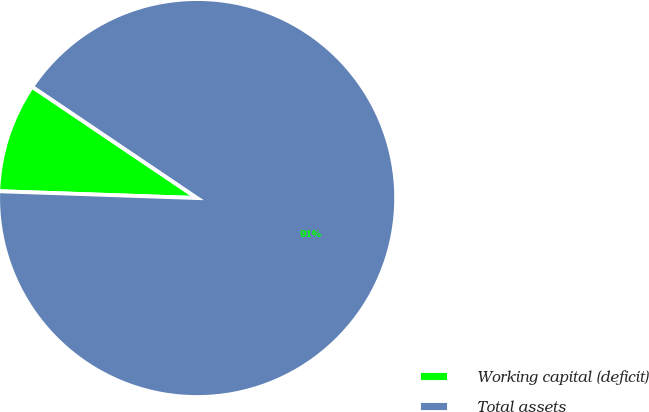Convert chart to OTSL. <chart><loc_0><loc_0><loc_500><loc_500><pie_chart><fcel>Working capital (deficit)<fcel>Total assets<nl><fcel>8.9%<fcel>91.1%<nl></chart> 